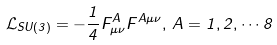Convert formula to latex. <formula><loc_0><loc_0><loc_500><loc_500>\mathcal { L } _ { S U ( 3 ) } = - \frac { 1 } { 4 } F ^ { A } _ { \mu \nu } F ^ { A \mu \nu } , \, A = 1 , 2 , \cdots 8</formula> 